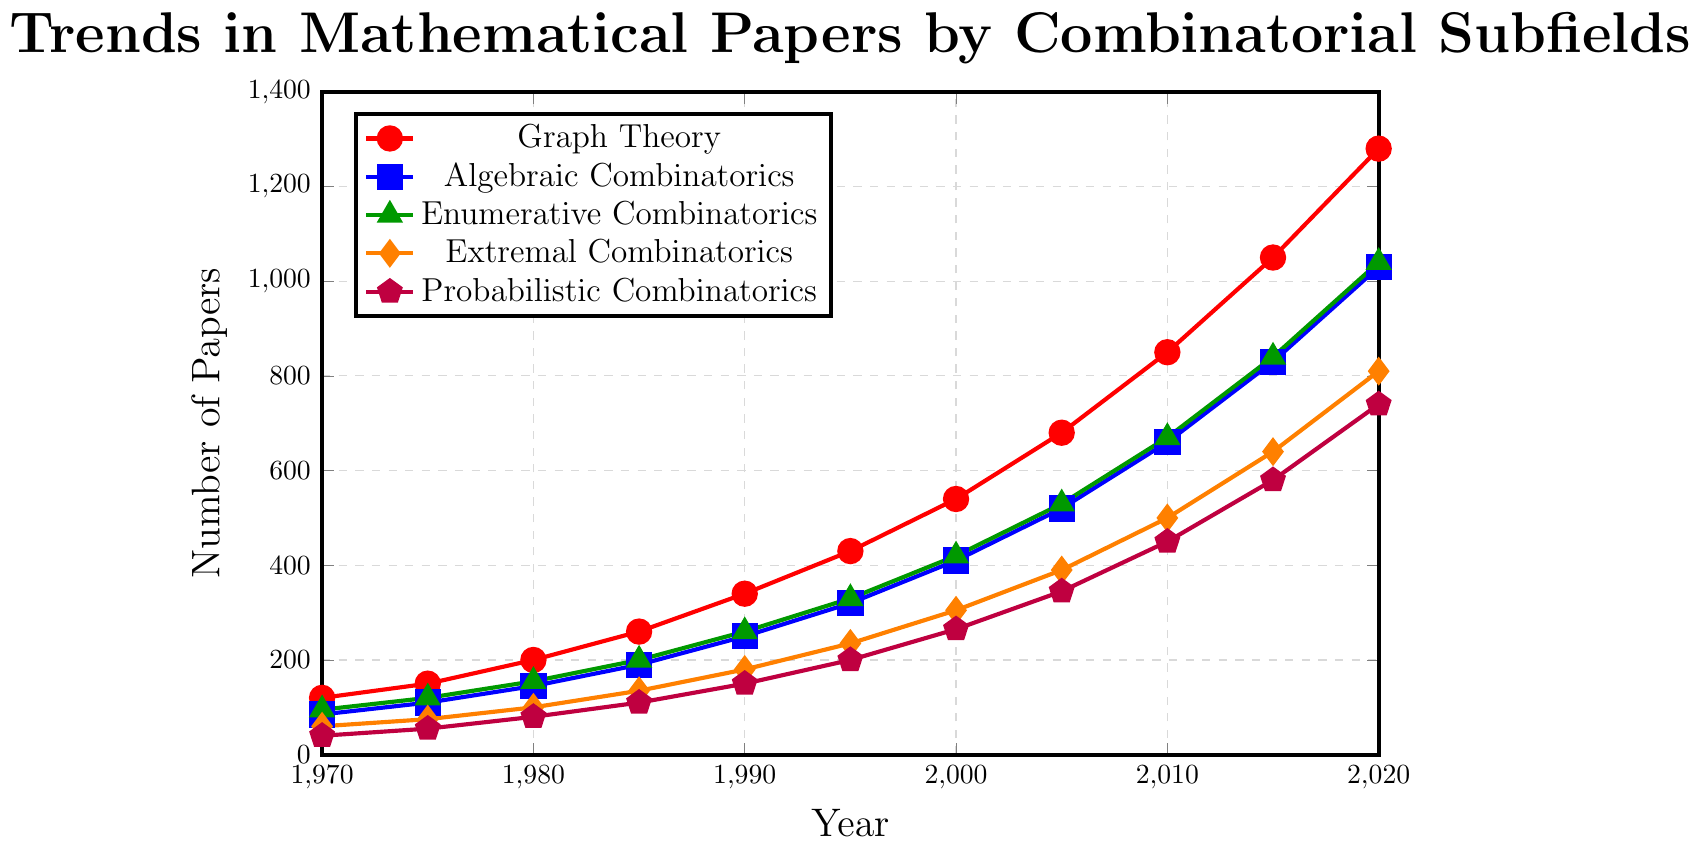What's the total number of papers published in all subfields in 1970? We need to sum the number of papers from each subfield in 1970: Graph Theory (120), Algebraic Combinatorics (85), Enumerative Combinatorics (95), Extremal Combinatorics (60), Probabilistic Combinatorics (40). 120 + 85 + 95 + 60 + 40 = 400
Answer: 400 Which subfield showed the greatest increase in the number of papers published from 1970 to 2020? We calculate the increase for each subfield: Graph Theory (1280 - 120 = 1160), Algebraic Combinatorics (1030 - 85 = 945), Enumerative Combinatorics (1040 - 95 = 945), Extremal Combinatorics (810 - 60 = 750), Probabilistic Combinatorics (740 - 40 = 700). The greatest increase is in Graph Theory with 1160 papers
Answer: Graph Theory In which year did Enumerative Combinatorics surpass 500 papers published annually? We look at the data for Enumerative Combinatorics: the number of papers surpassed 500 in 2005 (530 papers)
Answer: 2005 What is the average number of papers published in Extremal Combinatorics from 1970 to 2020? Sum the numbers for Extremal Combinatorics from 1970 to 2020 and divide by the number of years: (60 + 75 + 100 + 135 + 180 + 235 + 305 + 390 + 500 + 640 + 810) / 11 = 3330 / 11 = 302.7
Answer: 302.7 Which subfield had the smallest number of papers published in 2005? We compare the numbers for 2005: Graph Theory (680), Algebraic Combinatorics (520), Enumerative Combinatorics (530), Extremal Combinatorics (390), Probabilistic Combinatorics (345). The smallest is Probabilistic Combinatorics with 345 papers
Answer: Probabilistic Combinatorics How many more papers were published in Graph Theory than in Probabilistic Combinatorics in 2020? Subtract the number in Probabilistic Combinatorics from the number in Graph Theory in 2020: 1280 - 740 = 540
Answer: 540 What is the trend in the number of papers published in Algebraic Combinatorics over the 50 years? By observing the yearly numbers in Algebraic Combinatorics, we see a consistent upward trend from 85 in 1970 to 1030 in 2020
Answer: Upward trend Which subfield had the closest number of papers published to Enumerative Combinatorics in 2015? We compare the numbers for 2015: Enumerative Combinatorics (840), Graph Theory (1050), Algebraic Combinatorics (830), Extremal Combinatorics (640), Probabilistic Combinatorics (580). Algebraic Combinatorics had 830, which is closest to 840
Answer: Algebraic Combinatorics What is the total number of papers published in 1990 across all subfields? Sum the numbers from each subfield in 1990: Graph Theory (340), Algebraic Combinatorics (250), Enumerative Combinatorics (260), Extremal Combinatorics (180), Probabilistic Combinatorics (150). 340 + 250 + 260 + 180 + 150 = 1180
Answer: 1180 